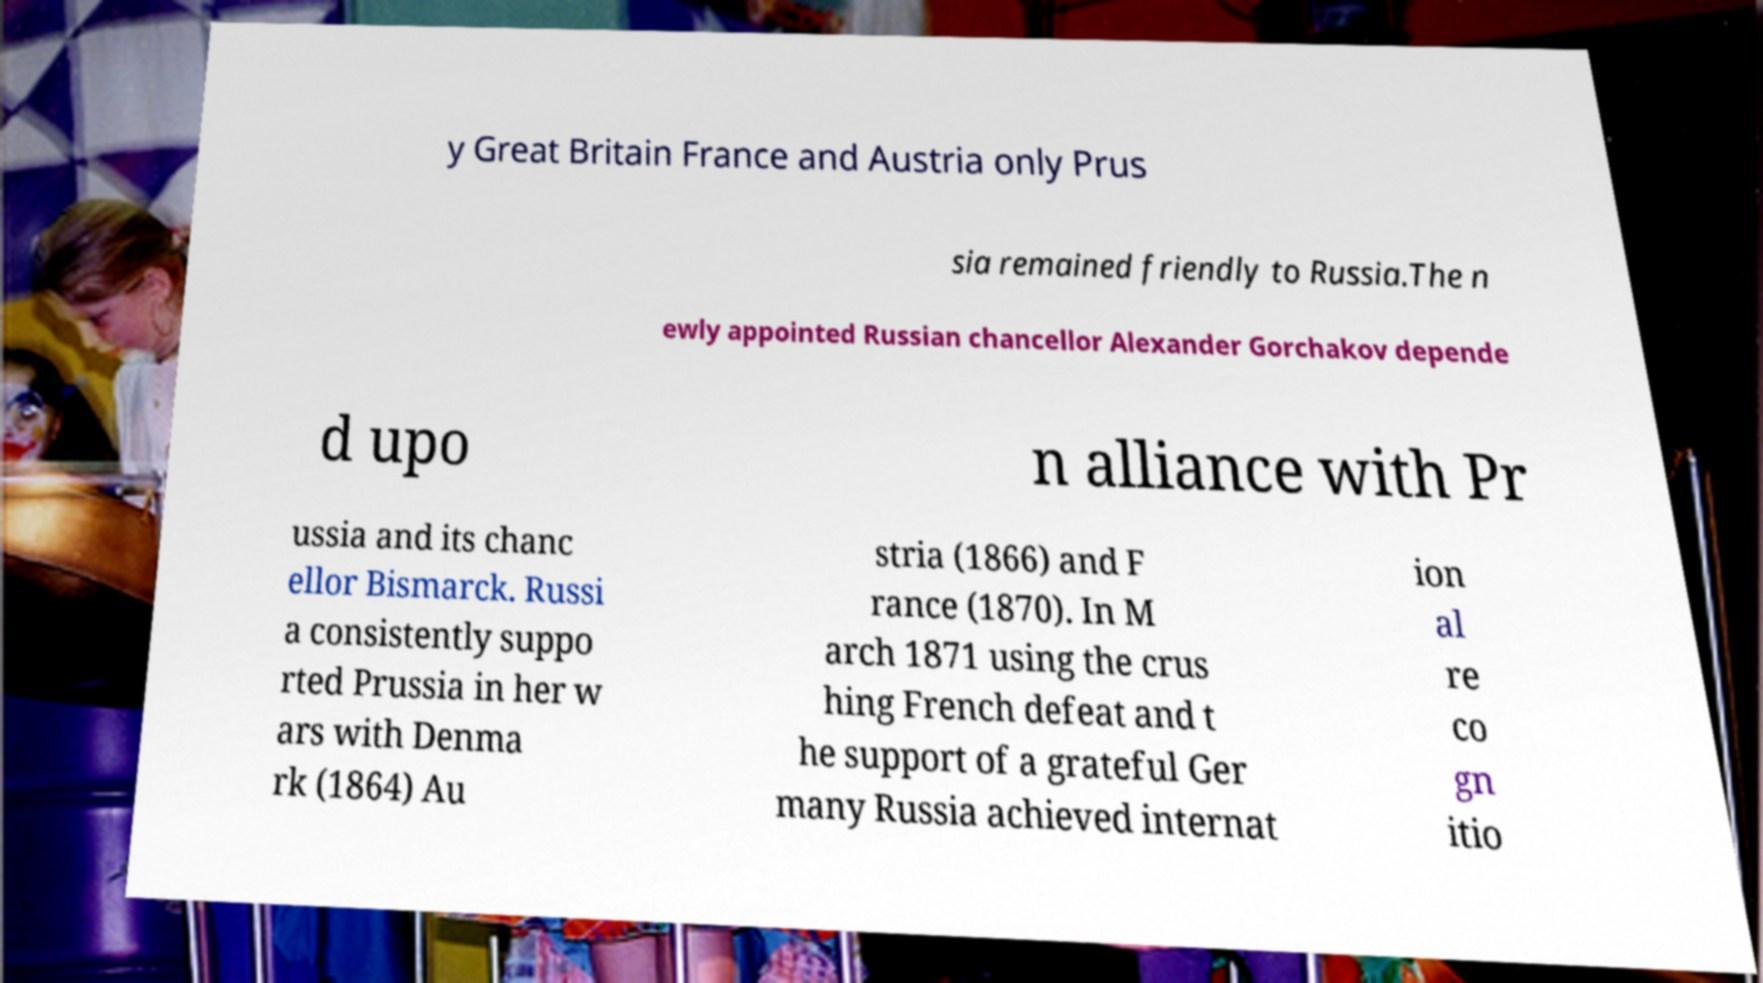There's text embedded in this image that I need extracted. Can you transcribe it verbatim? y Great Britain France and Austria only Prus sia remained friendly to Russia.The n ewly appointed Russian chancellor Alexander Gorchakov depende d upo n alliance with Pr ussia and its chanc ellor Bismarck. Russi a consistently suppo rted Prussia in her w ars with Denma rk (1864) Au stria (1866) and F rance (1870). In M arch 1871 using the crus hing French defeat and t he support of a grateful Ger many Russia achieved internat ion al re co gn itio 